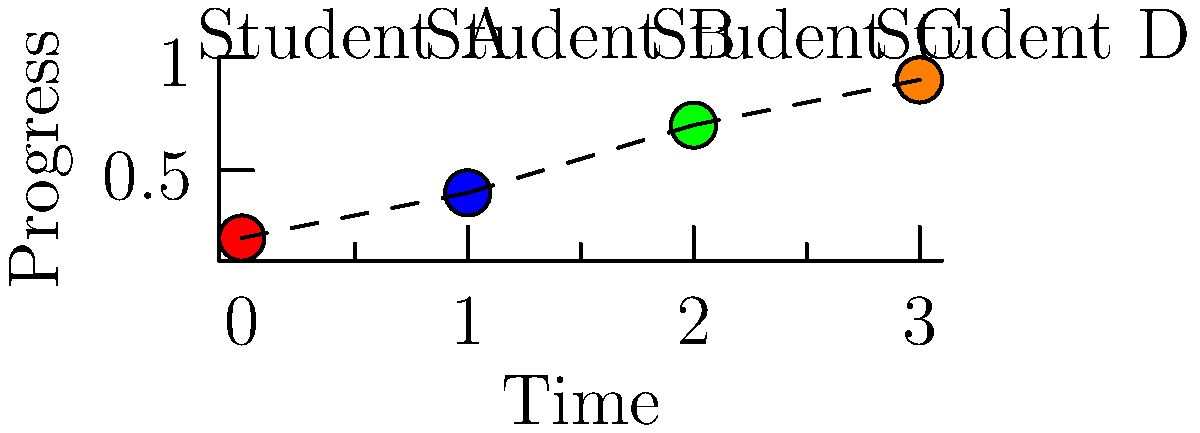In a personalized learning environment, the graph shows the progress of four students (A, B, C, and D) over time. Based on the pattern observed, which student is likely to benefit most from an accelerated learning program? To determine which student would benefit most from an accelerated learning program, we need to analyze the progress pattern for each student:

1. Student A (red): Shows the lowest initial progress (0.2) but demonstrates steady improvement.
2. Student B (blue): Starts higher than A (0.4) and shows consistent growth.
3. Student C (green): Begins at a higher level (0.7) and shows significant improvement.
4. Student D (orange): Starts at the highest level (0.9) and maintains that high level.

The pattern we're looking for is a combination of high achievement and rapid progress. Student C fits this profile best:

1. High achievement: Student C starts at a relatively high level (0.7).
2. Rapid progress: The slope of the line connecting C's two data points is the steepest, indicating the fastest rate of improvement.

Student C demonstrates both a strong foundation (starting at a high level) and the ability to make significant progress quickly. This combination suggests that Student C has the capacity to handle more challenging material and would likely benefit most from an accelerated learning program.

While Student D shows the highest overall achievement, their progress is less pronounced, suggesting they might already be working at an accelerated pace. Students A and B, while showing good progress, are not yet at the same level of achievement as C.
Answer: Student C 